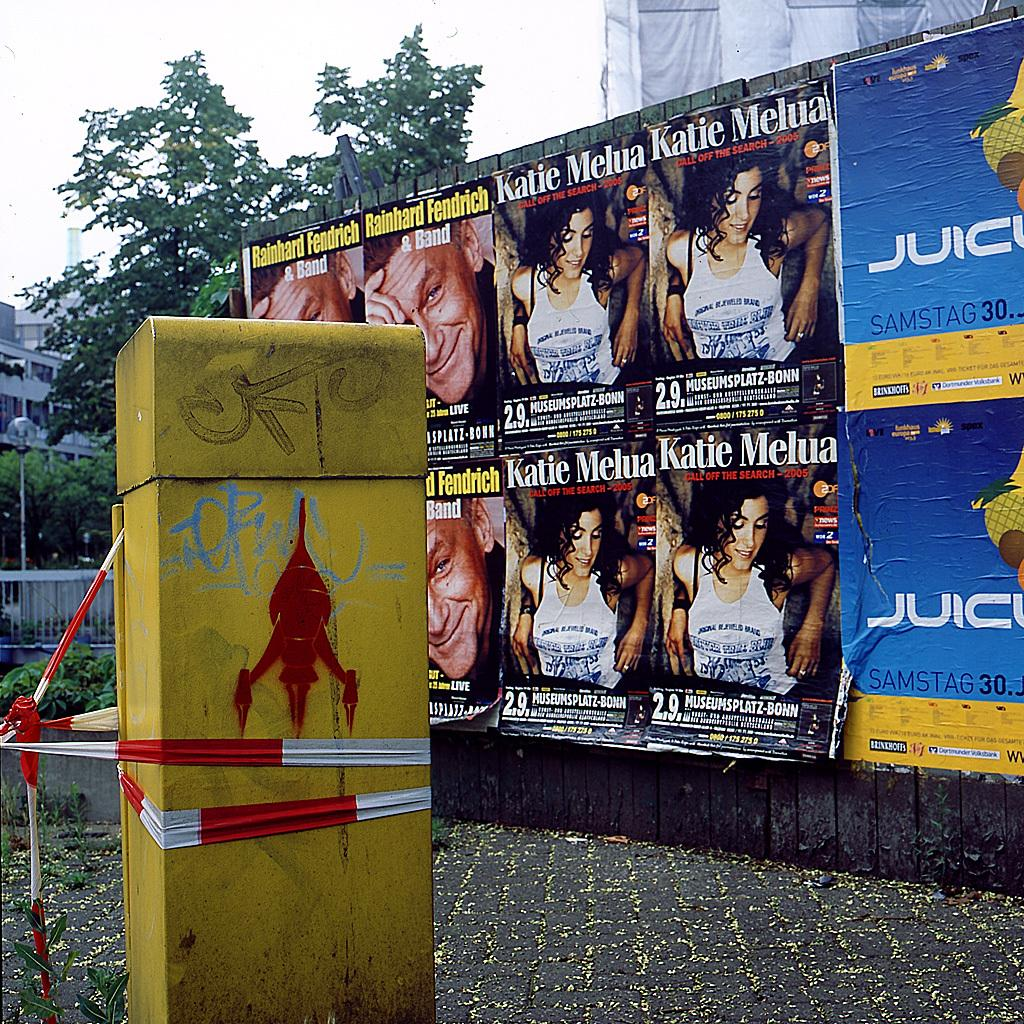<image>
Share a concise interpretation of the image provided. A wall full of flyers and posters, most of which say Katie Melua. 